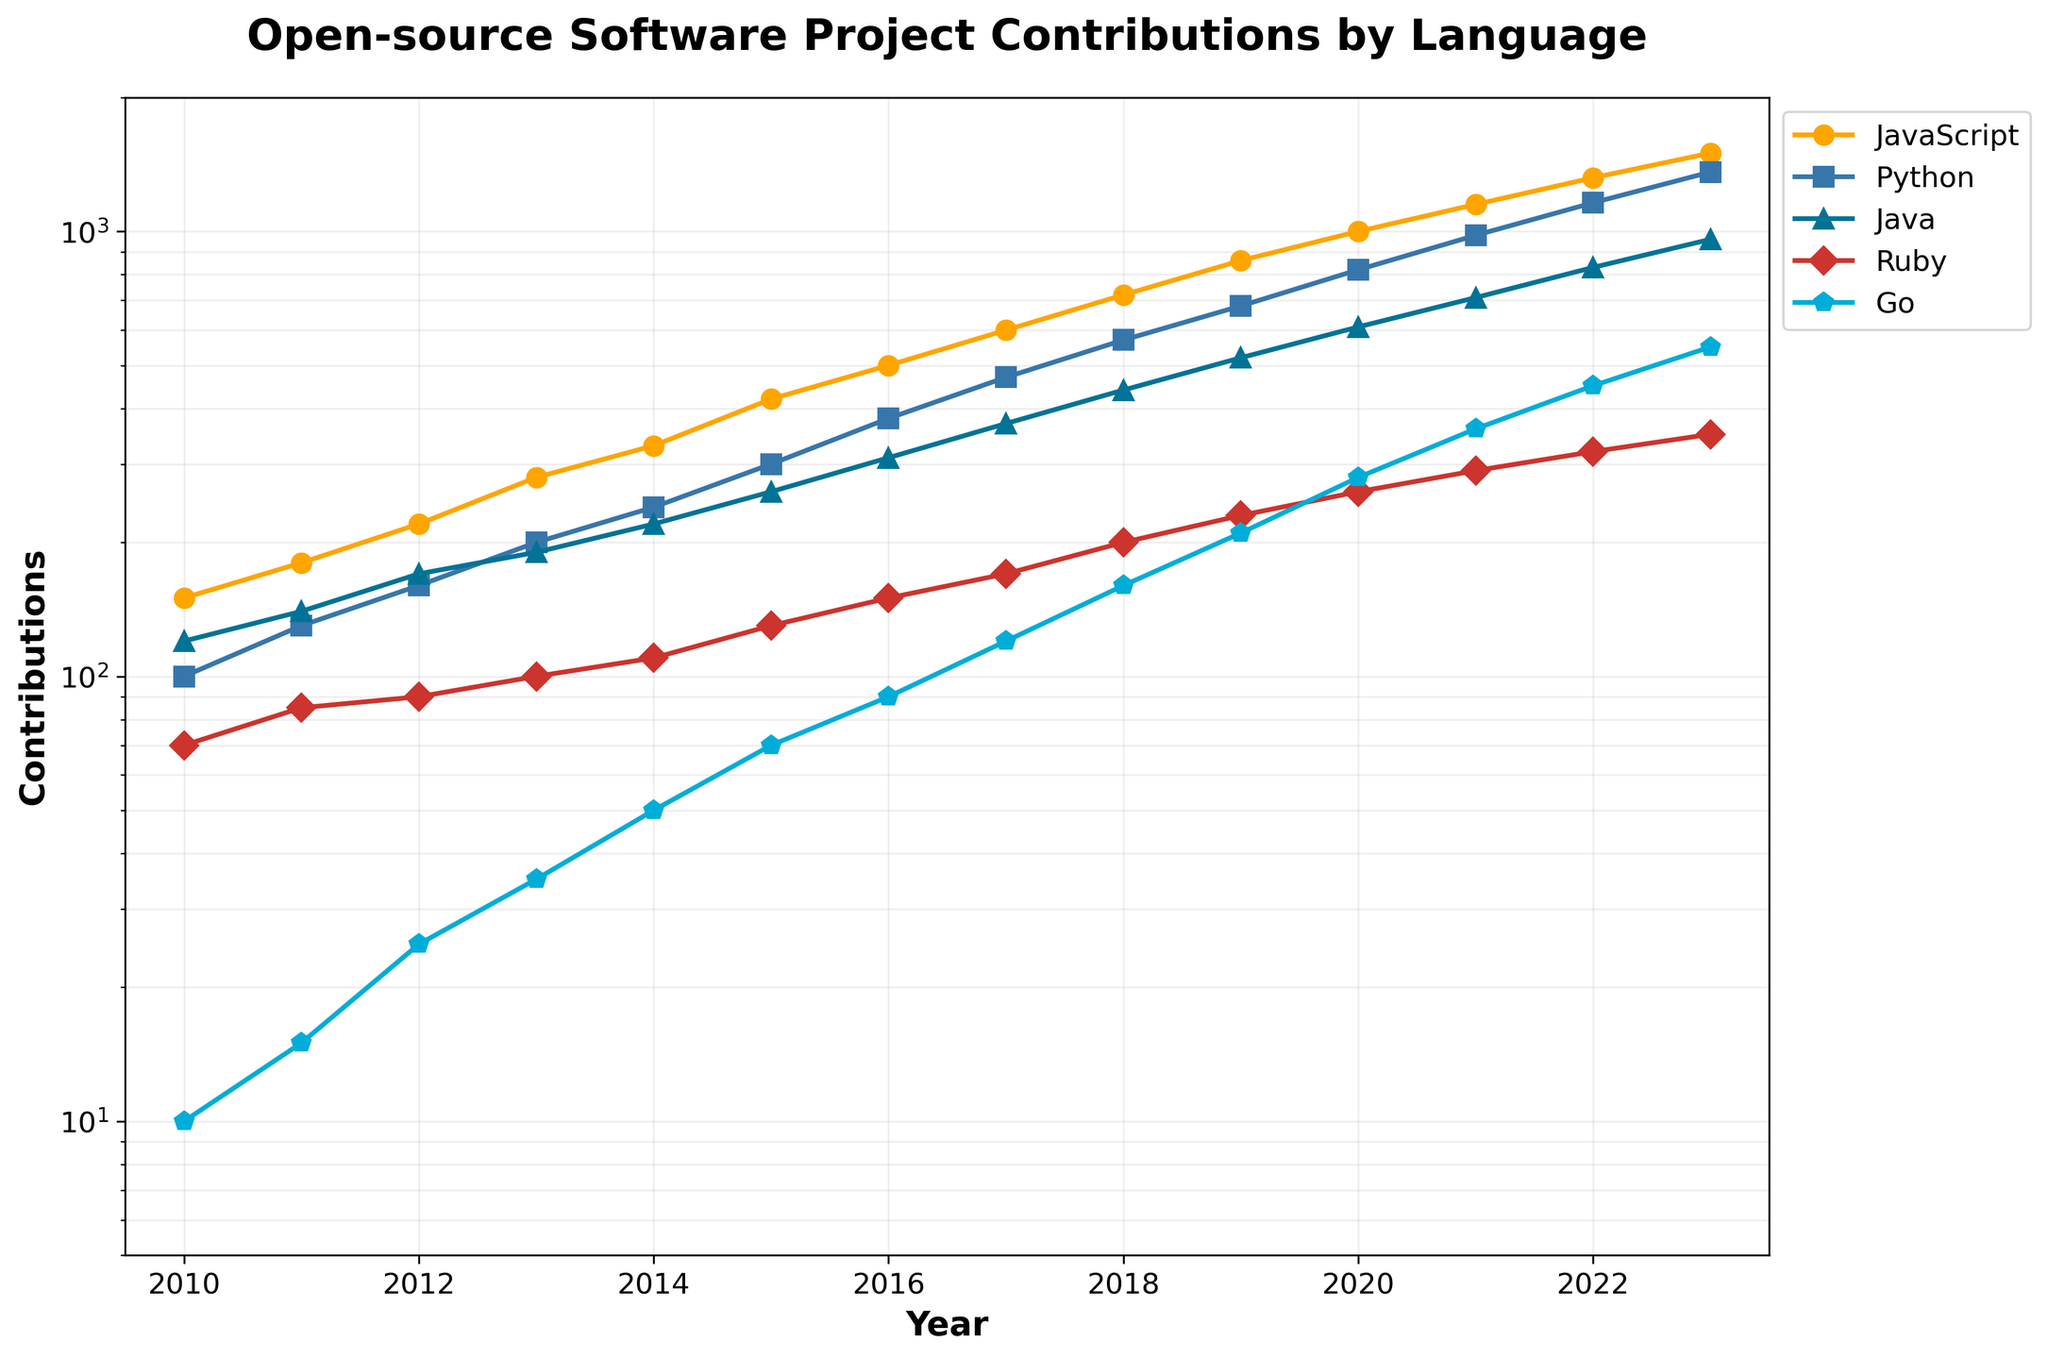What is the title of the plot? The title of the plot is generally placed at the top of the figure and should provide an overview of the visualization.
Answer: Open-source Software Project Contributions by Language Which language had the highest contributions in 2015? By looking at the plot, locate the year 2015 on the x-axis, then check the y-axis values for each line representing a language. The line that reaches the highest value represents the language with the highest contributions.
Answer: JavaScript In which year did Python contributions surpass 1000? Locate the line representing Python (typically color-coded) and follow it until it crosses the 1000 mark on the y-axis. The corresponding value on the x-axis is the year.
Answer: 2021 What was the approximate difference in contributions between JavaScript and Ruby in 2020? Find the year 2020 on the x-axis, then identify the contributions for both JavaScript and Ruby on the y-axis. Subtract Ruby's contributions from JavaScript's contributions.
Answer: 740 How many data points are there for each language? Count the number of distinct x-axis ticks or data markers for any language. Since the data spans from 2010 to 2023, inclusive, the count is 14 years.
Answer: 14 Which language shows the steepest increase in contributions over time up to 2023? Visually estimate the slope of each line. The language with the line that shows the most significant upward trend indicates the steepest increase in contributions.
Answer: JavaScript By how much did the Go contributions increase from 2011 to 2015? Locate the contributions for Go in 2011 and 2015 on the y-axis. Subtract the 2011 value from the 2015 value to find the increase.
Answer: 55 Which two languages had almost similar contributions in 2012? Find the year 2012 on the x-axis and compare the y-axis values for all lines. Identify two lines that have closely matching values.
Answer: Java and Python What is the general trend in contributions for Ruby from 2010 to 2023? Observe the line representing Ruby and note its direction and slope over time. Whether it climbs, declines, or stays relatively flat indicates the general trend.
Answer: Increasing How does the contribution growth rate of Go compare to that of Python? Compare the respective slopes of the Go and Python lines from 2010 to 2023. The line with the steeper slope has a higher growth rate.
Answer: Slower 